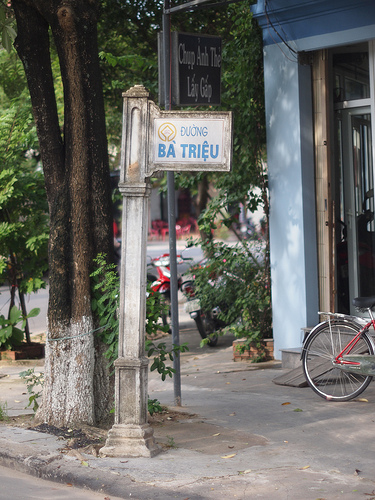Please provide a short description for this region: [0.19, 0.6, 0.37, 0.88]. The region [0.19, 0.6, 0.37, 0.88] contains white paint on a tree. 